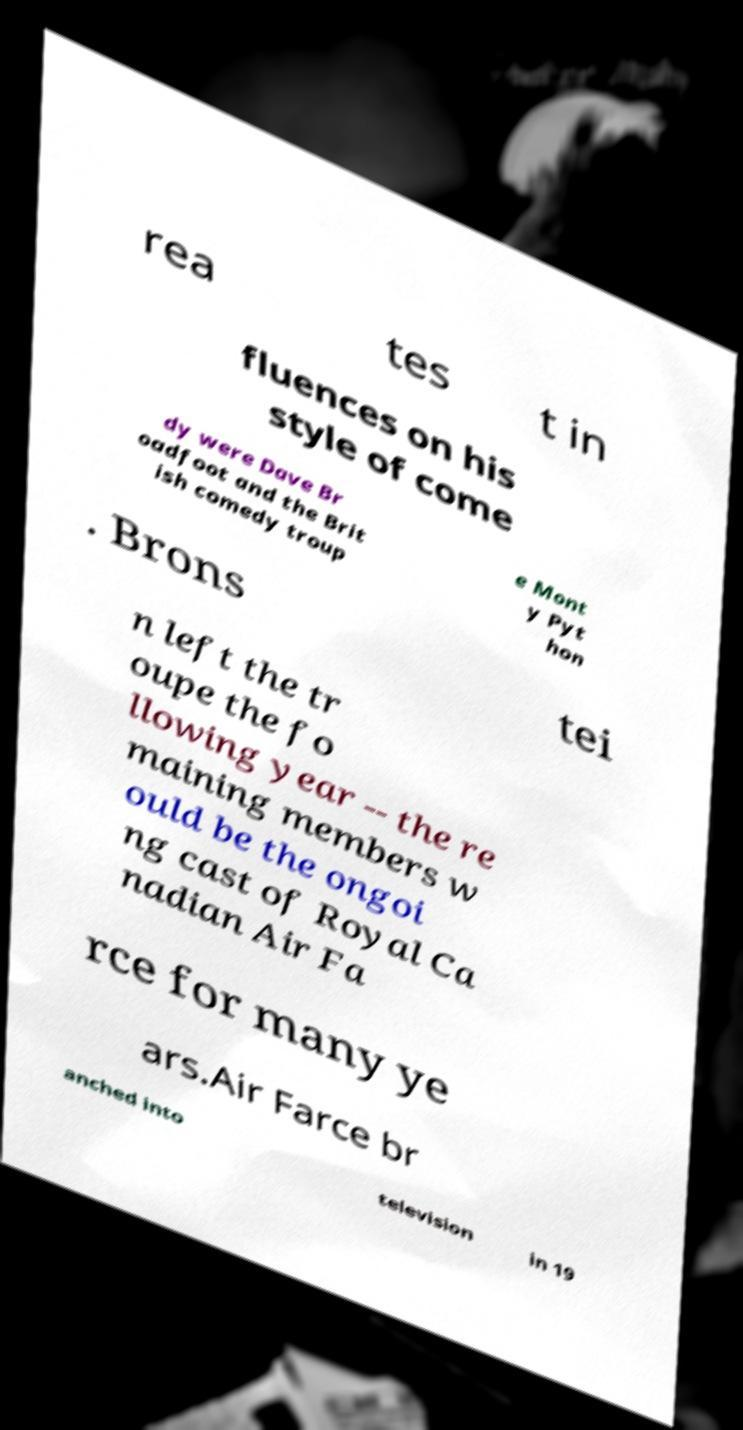For documentation purposes, I need the text within this image transcribed. Could you provide that? rea tes t in fluences on his style of come dy were Dave Br oadfoot and the Brit ish comedy troup e Mont y Pyt hon . Brons tei n left the tr oupe the fo llowing year -- the re maining members w ould be the ongoi ng cast of Royal Ca nadian Air Fa rce for many ye ars.Air Farce br anched into television in 19 